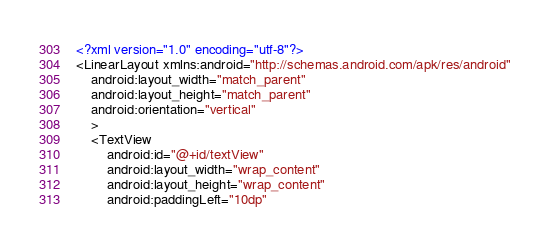<code> <loc_0><loc_0><loc_500><loc_500><_XML_><?xml version="1.0" encoding="utf-8"?>
<LinearLayout xmlns:android="http://schemas.android.com/apk/res/android"
    android:layout_width="match_parent"
    android:layout_height="match_parent"
    android:orientation="vertical"
    >
    <TextView
        android:id="@+id/textView"
        android:layout_width="wrap_content"
        android:layout_height="wrap_content"
        android:paddingLeft="10dp"</code> 